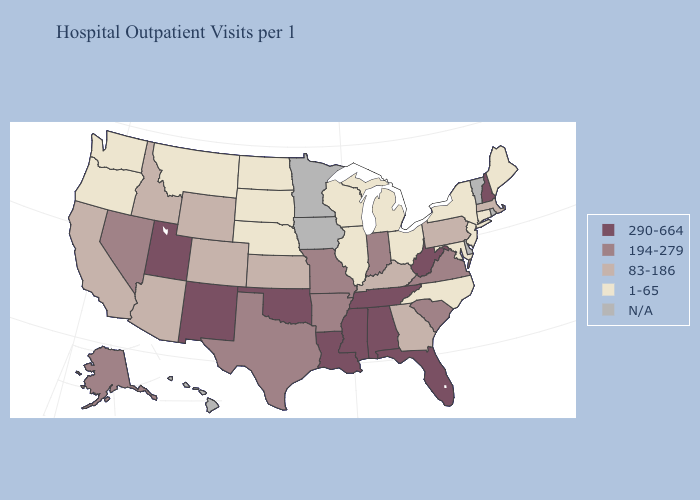Name the states that have a value in the range N/A?
Quick response, please. Delaware, Hawaii, Iowa, Minnesota, Rhode Island, Vermont. Name the states that have a value in the range 194-279?
Keep it brief. Alaska, Arkansas, Indiana, Missouri, Nevada, South Carolina, Texas, Virginia. Does Kentucky have the lowest value in the USA?
Write a very short answer. No. Does the map have missing data?
Keep it brief. Yes. Does Pennsylvania have the highest value in the Northeast?
Give a very brief answer. No. What is the lowest value in the USA?
Quick response, please. 1-65. Among the states that border North Dakota , which have the lowest value?
Concise answer only. Montana, South Dakota. What is the lowest value in the South?
Keep it brief. 1-65. Among the states that border Alabama , which have the highest value?
Answer briefly. Florida, Mississippi, Tennessee. What is the value of New Hampshire?
Concise answer only. 290-664. Among the states that border Texas , does Arkansas have the lowest value?
Keep it brief. Yes. What is the value of Pennsylvania?
Be succinct. 83-186. Does the map have missing data?
Give a very brief answer. Yes. 